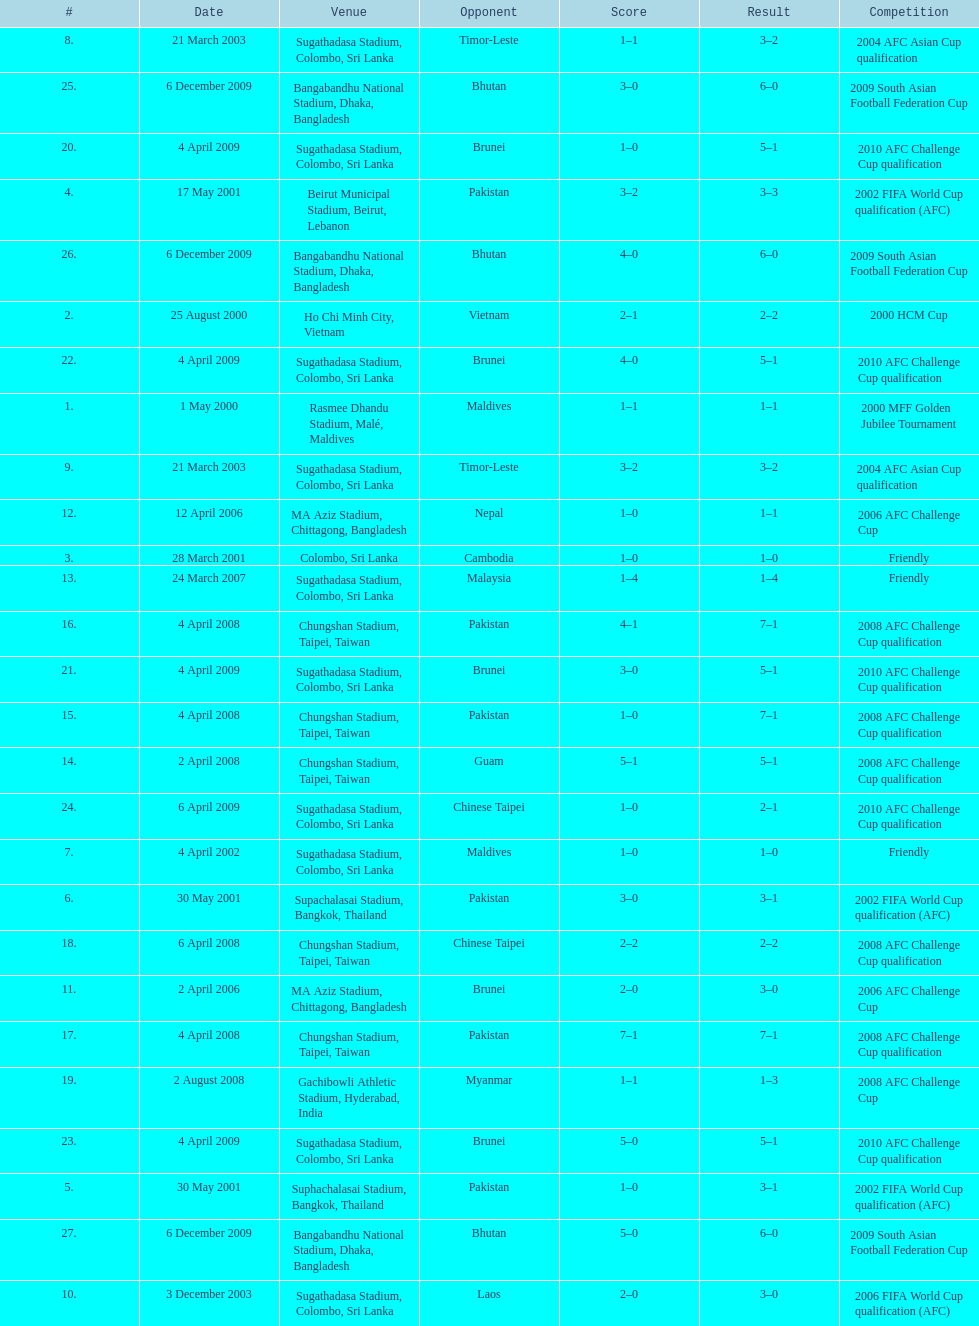Give me the full table as a dictionary. {'header': ['#', 'Date', 'Venue', 'Opponent', 'Score', 'Result', 'Competition'], 'rows': [['8.', '21 March 2003', 'Sugathadasa Stadium, Colombo, Sri Lanka', 'Timor-Leste', '1–1', '3–2', '2004 AFC Asian Cup qualification'], ['25.', '6 December 2009', 'Bangabandhu National Stadium, Dhaka, Bangladesh', 'Bhutan', '3–0', '6–0', '2009 South Asian Football Federation Cup'], ['20.', '4 April 2009', 'Sugathadasa Stadium, Colombo, Sri Lanka', 'Brunei', '1–0', '5–1', '2010 AFC Challenge Cup qualification'], ['4.', '17 May 2001', 'Beirut Municipal Stadium, Beirut, Lebanon', 'Pakistan', '3–2', '3–3', '2002 FIFA World Cup qualification (AFC)'], ['26.', '6 December 2009', 'Bangabandhu National Stadium, Dhaka, Bangladesh', 'Bhutan', '4–0', '6–0', '2009 South Asian Football Federation Cup'], ['2.', '25 August 2000', 'Ho Chi Minh City, Vietnam', 'Vietnam', '2–1', '2–2', '2000 HCM Cup'], ['22.', '4 April 2009', 'Sugathadasa Stadium, Colombo, Sri Lanka', 'Brunei', '4–0', '5–1', '2010 AFC Challenge Cup qualification'], ['1.', '1 May 2000', 'Rasmee Dhandu Stadium, Malé, Maldives', 'Maldives', '1–1', '1–1', '2000 MFF Golden Jubilee Tournament'], ['9.', '21 March 2003', 'Sugathadasa Stadium, Colombo, Sri Lanka', 'Timor-Leste', '3–2', '3–2', '2004 AFC Asian Cup qualification'], ['12.', '12 April 2006', 'MA Aziz Stadium, Chittagong, Bangladesh', 'Nepal', '1–0', '1–1', '2006 AFC Challenge Cup'], ['3.', '28 March 2001', 'Colombo, Sri Lanka', 'Cambodia', '1–0', '1–0', 'Friendly'], ['13.', '24 March 2007', 'Sugathadasa Stadium, Colombo, Sri Lanka', 'Malaysia', '1–4', '1–4', 'Friendly'], ['16.', '4 April 2008', 'Chungshan Stadium, Taipei, Taiwan', 'Pakistan', '4–1', '7–1', '2008 AFC Challenge Cup qualification'], ['21.', '4 April 2009', 'Sugathadasa Stadium, Colombo, Sri Lanka', 'Brunei', '3–0', '5–1', '2010 AFC Challenge Cup qualification'], ['15.', '4 April 2008', 'Chungshan Stadium, Taipei, Taiwan', 'Pakistan', '1–0', '7–1', '2008 AFC Challenge Cup qualification'], ['14.', '2 April 2008', 'Chungshan Stadium, Taipei, Taiwan', 'Guam', '5–1', '5–1', '2008 AFC Challenge Cup qualification'], ['24.', '6 April 2009', 'Sugathadasa Stadium, Colombo, Sri Lanka', 'Chinese Taipei', '1–0', '2–1', '2010 AFC Challenge Cup qualification'], ['7.', '4 April 2002', 'Sugathadasa Stadium, Colombo, Sri Lanka', 'Maldives', '1–0', '1–0', 'Friendly'], ['6.', '30 May 2001', 'Supachalasai Stadium, Bangkok, Thailand', 'Pakistan', '3–0', '3–1', '2002 FIFA World Cup qualification (AFC)'], ['18.', '6 April 2008', 'Chungshan Stadium, Taipei, Taiwan', 'Chinese Taipei', '2–2', '2–2', '2008 AFC Challenge Cup qualification'], ['11.', '2 April 2006', 'MA Aziz Stadium, Chittagong, Bangladesh', 'Brunei', '2–0', '3–0', '2006 AFC Challenge Cup'], ['17.', '4 April 2008', 'Chungshan Stadium, Taipei, Taiwan', 'Pakistan', '7–1', '7–1', '2008 AFC Challenge Cup qualification'], ['19.', '2 August 2008', 'Gachibowli Athletic Stadium, Hyderabad, India', 'Myanmar', '1–1', '1–3', '2008 AFC Challenge Cup'], ['23.', '4 April 2009', 'Sugathadasa Stadium, Colombo, Sri Lanka', 'Brunei', '5–0', '5–1', '2010 AFC Challenge Cup qualification'], ['5.', '30 May 2001', 'Suphachalasai Stadium, Bangkok, Thailand', 'Pakistan', '1–0', '3–1', '2002 FIFA World Cup qualification (AFC)'], ['27.', '6 December 2009', 'Bangabandhu National Stadium, Dhaka, Bangladesh', 'Bhutan', '5–0', '6–0', '2009 South Asian Football Federation Cup'], ['10.', '3 December 2003', 'Sugathadasa Stadium, Colombo, Sri Lanka', 'Laos', '2–0', '3–0', '2006 FIFA World Cup qualification (AFC)']]} How many times was laos the opponent? 1. 